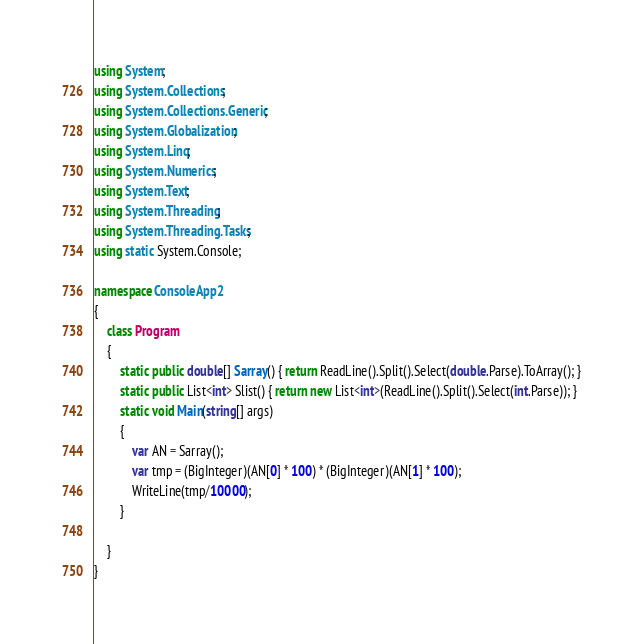<code> <loc_0><loc_0><loc_500><loc_500><_C#_>using System;
using System.Collections;
using System.Collections.Generic;
using System.Globalization;
using System.Linq;
using System.Numerics;
using System.Text;
using System.Threading;
using System.Threading.Tasks;
using static System.Console;

namespace ConsoleApp2
{
    class Program
    {
        static public double[] Sarray() { return ReadLine().Split().Select(double.Parse).ToArray(); }
        static public List<int> Slist() { return new List<int>(ReadLine().Split().Select(int.Parse)); }
        static void Main(string[] args)
        {
            var AN = Sarray();
            var tmp = (BigInteger)(AN[0] * 100) * (BigInteger)(AN[1] * 100);
            WriteLine(tmp/10000);
        }

    }
}
</code> 